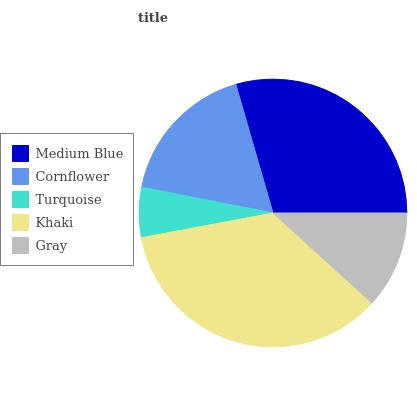Is Turquoise the minimum?
Answer yes or no. Yes. Is Khaki the maximum?
Answer yes or no. Yes. Is Cornflower the minimum?
Answer yes or no. No. Is Cornflower the maximum?
Answer yes or no. No. Is Medium Blue greater than Cornflower?
Answer yes or no. Yes. Is Cornflower less than Medium Blue?
Answer yes or no. Yes. Is Cornflower greater than Medium Blue?
Answer yes or no. No. Is Medium Blue less than Cornflower?
Answer yes or no. No. Is Cornflower the high median?
Answer yes or no. Yes. Is Cornflower the low median?
Answer yes or no. Yes. Is Turquoise the high median?
Answer yes or no. No. Is Turquoise the low median?
Answer yes or no. No. 